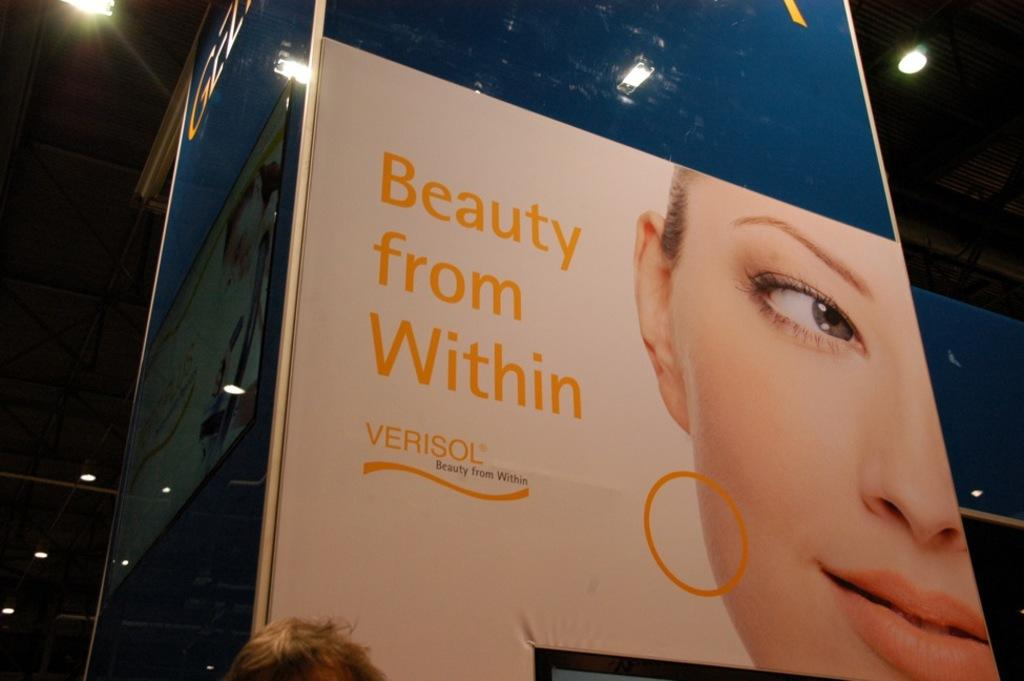What is located in the center of the image? There are boards in the center of the image. What can be seen at the top of the image? There are lights at the top of the image. Can you describe the person's head visible at the bottom of the image? A person's head is visible at the bottom of the image. What type of wool is being used to make the airport visible in the image? There is no airport present in the image, and wool is not mentioned in the provided facts. How does the pump function in the image? There is no pump present in the image. 